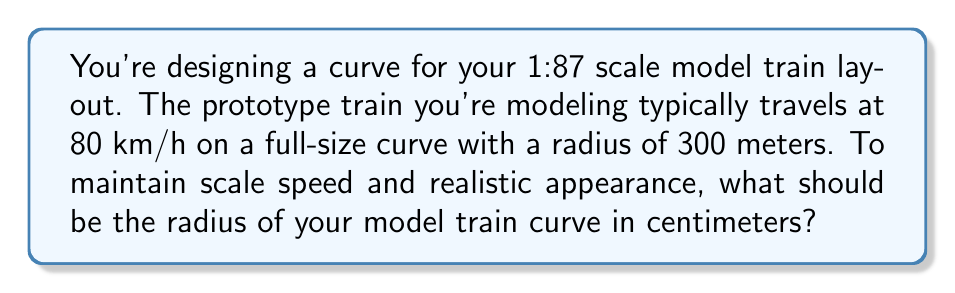Can you solve this math problem? To solve this problem, we need to consider the scale factor and the relationship between speed and curve radius. Let's approach this step-by-step:

1) First, let's consider the scale factor. The model is 1:87 scale, which means:

   $\text{Scale factor} = \frac{1}{87}$

2) The full-size curve radius is 300 meters. To convert this to the model scale, we multiply by the scale factor:

   $\text{Model radius} = 300 \text{ m} \times \frac{1}{87} = \frac{300}{87} \text{ m}$

3) Now, we need to consider the relationship between speed and curve radius. For a given lateral acceleration, the radius is proportional to the square of the speed:

   $R \propto v^2$

4) We want to maintain the same relative speed in our model. The speed doesn't need to be scaled directly, but the ratio of speed squared to radius should be the same for both the prototype and the model:

   $\frac{v_{\text{prototype}}^2}{R_{\text{prototype}}} = \frac{v_{\text{model}}^2}{R_{\text{model}}}$

5) Since we're maintaining this ratio, and we've already scaled the radius, we don't need to consider the speed explicitly. The scaled radius we calculated in step 2 is the correct radius for our model.

6) Let's convert our result to centimeters:

   $R_{\text{model}} = \frac{300}{87} \text{ m} = \frac{30000}{87} \text{ cm} \approx 344.83 \text{ cm}$

Therefore, the optimal curve radius for your model train track is approximately 344.83 cm.
Answer: $344.83 \text{ cm}$ 